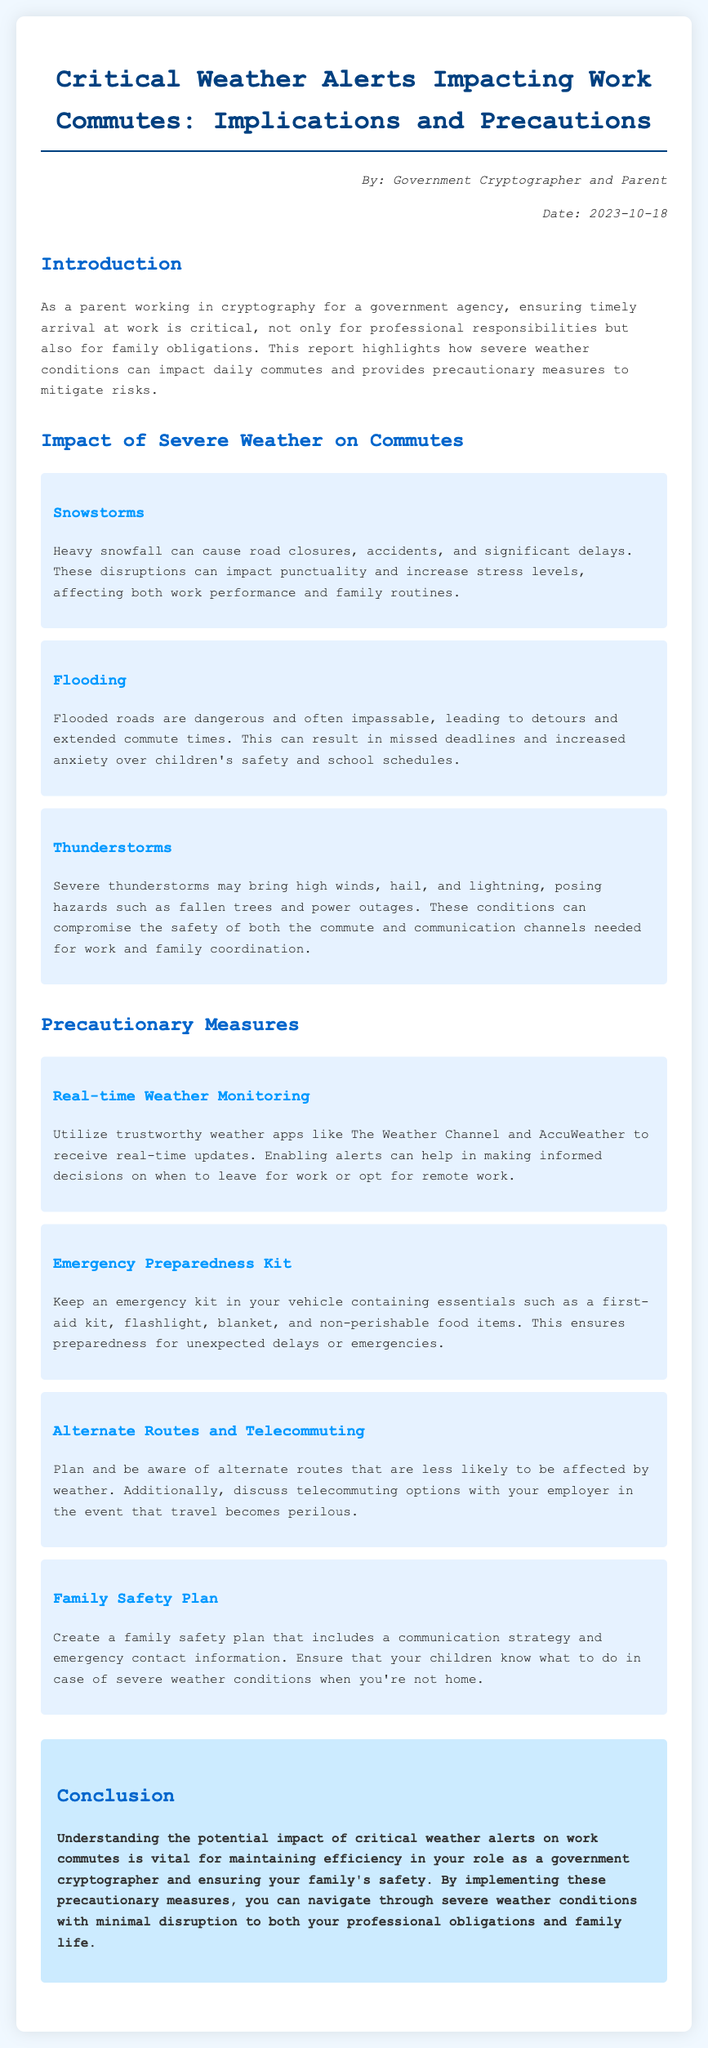What is the date of the report? The date of the report is mentioned in the author-date section as 2023-10-18.
Answer: 2023-10-18 Who is the author of the report? The author of the report is identified as Government Cryptographer and Parent.
Answer: Government Cryptographer and Parent What severe weather condition can cause road closures? The section discussing the impacts of severe weather lists snowstorms as causing road closures.
Answer: Snowstorms What precautionary measure involves real-time updates? The report suggests utilizing trustworthy weather apps for real-time weather monitoring.
Answer: Real-time Weather Monitoring What should be included in an emergency preparedness kit? An emergency preparedness kit should contain essentials such as a first-aid kit, flashlight, blanket, and non-perishable food items.
Answer: First-aid kit, flashlight, blanket, non-perishable food items How should families prepare for severe weather when a parent is not home? The report recommends creating a family safety plan that includes a communication strategy and emergency contact information.
Answer: Family safety plan What is a suggested communication strategy during severe weather? Families should establish a communication strategy as part of their family safety plan.
Answer: Communication strategy What is one effect of flooding mentioned in the report? Flooding can lead to detours and extended commute times, as per the report.
Answer: Extended commute times 